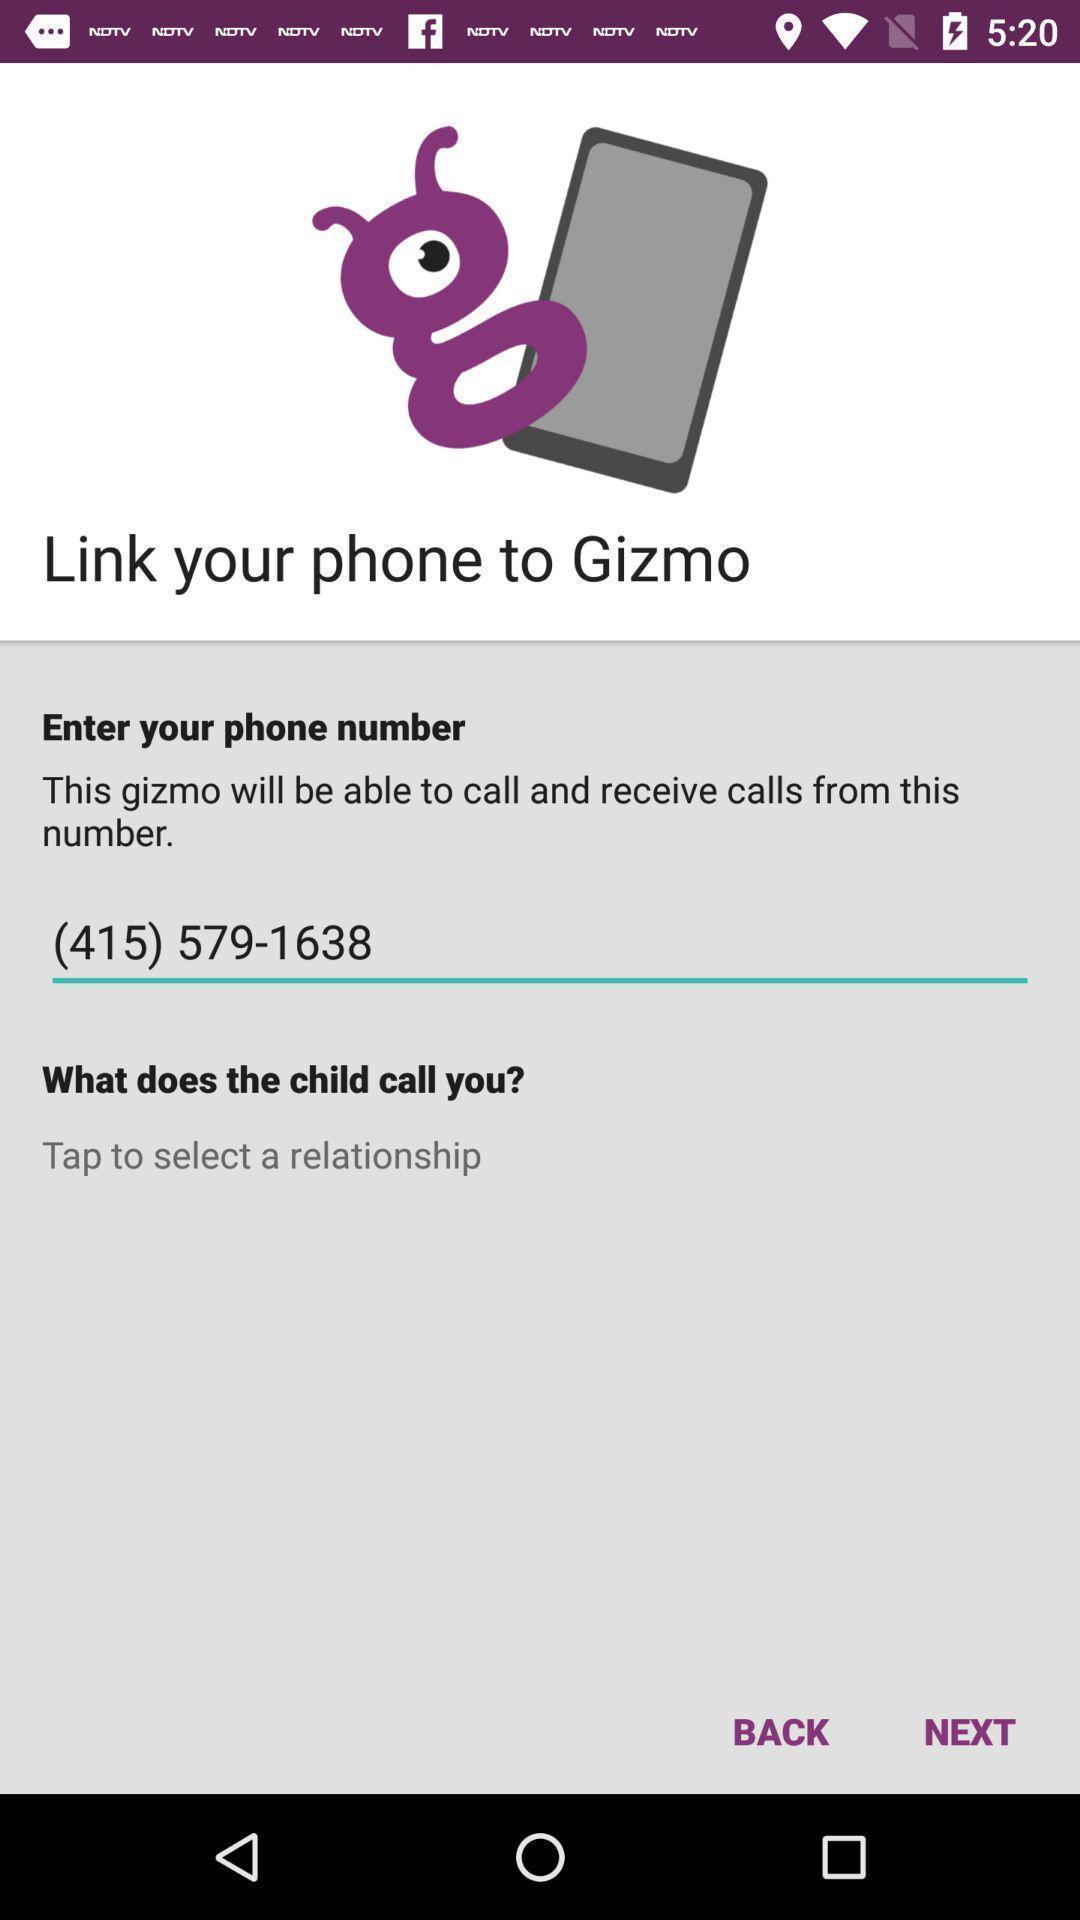What can you discern from this picture? Page for checking location of child. 